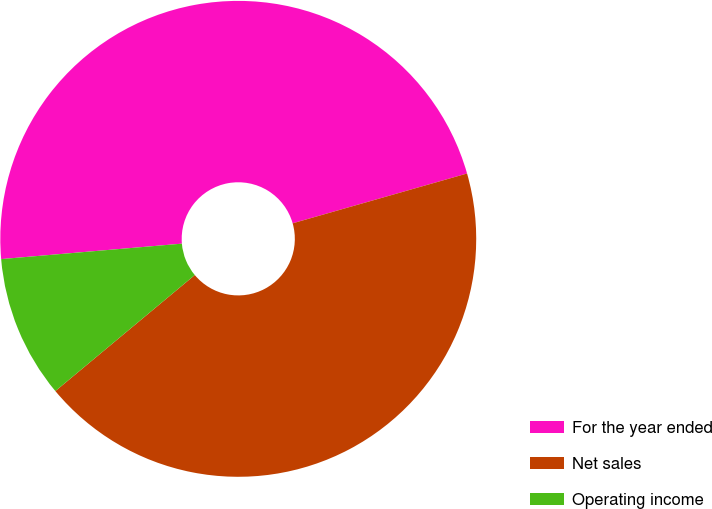Convert chart. <chart><loc_0><loc_0><loc_500><loc_500><pie_chart><fcel>For the year ended<fcel>Net sales<fcel>Operating income<nl><fcel>46.93%<fcel>43.38%<fcel>9.69%<nl></chart> 